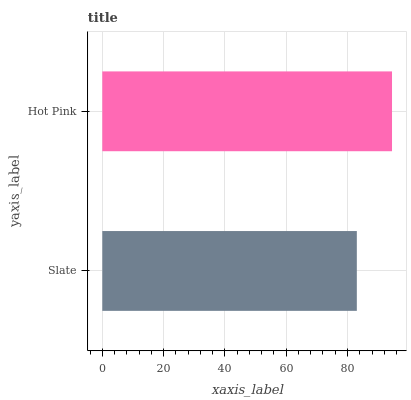Is Slate the minimum?
Answer yes or no. Yes. Is Hot Pink the maximum?
Answer yes or no. Yes. Is Hot Pink the minimum?
Answer yes or no. No. Is Hot Pink greater than Slate?
Answer yes or no. Yes. Is Slate less than Hot Pink?
Answer yes or no. Yes. Is Slate greater than Hot Pink?
Answer yes or no. No. Is Hot Pink less than Slate?
Answer yes or no. No. Is Hot Pink the high median?
Answer yes or no. Yes. Is Slate the low median?
Answer yes or no. Yes. Is Slate the high median?
Answer yes or no. No. Is Hot Pink the low median?
Answer yes or no. No. 